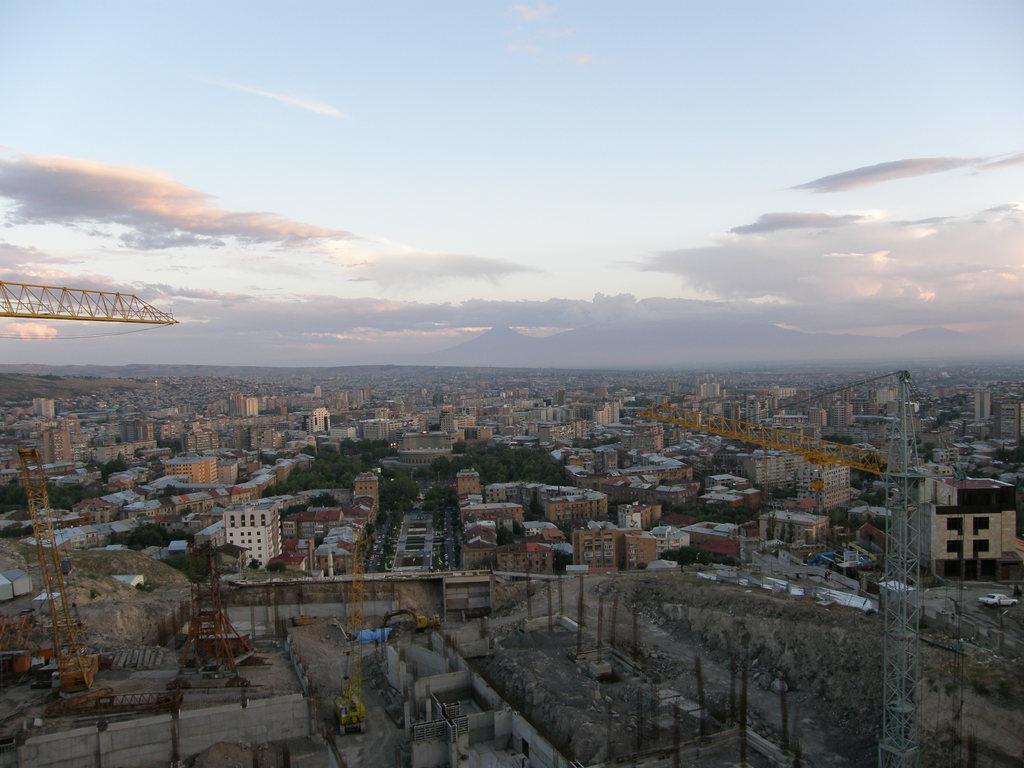Can you describe this image briefly? There are many buildings, tower cranes, trees and poles. In the background there is sky. 